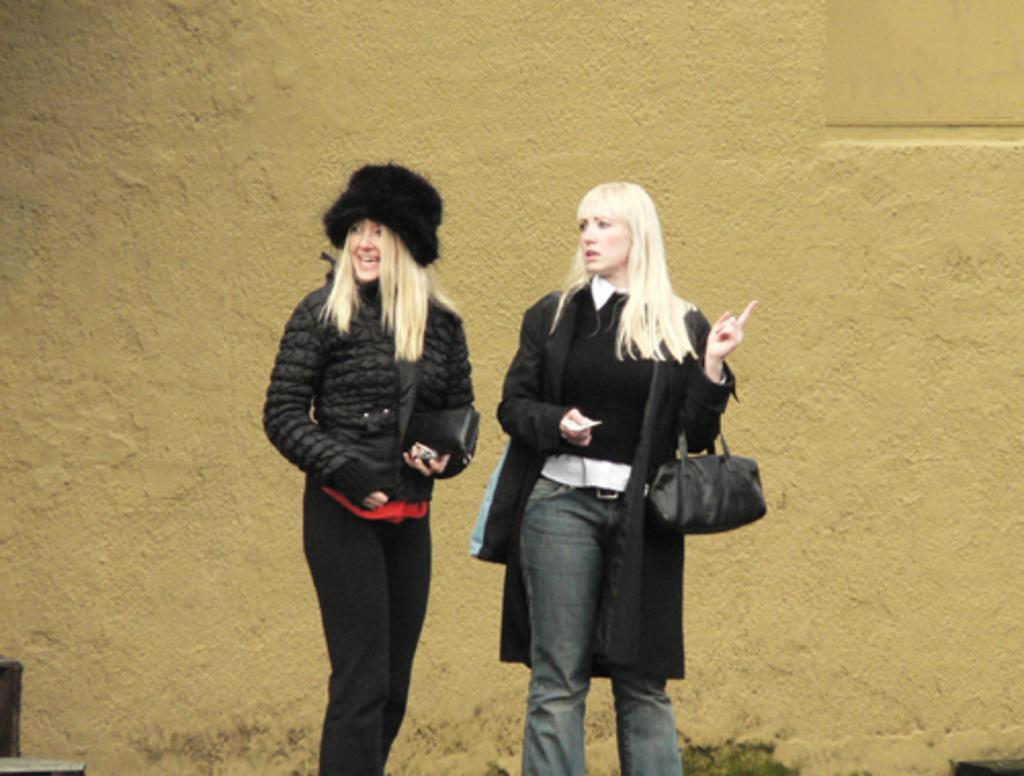How many people are in the image? There are two women in the image. What are the women doing in the image? The women are standing and smiling. What can be seen in the background of the image? There is a wall in the background of the image. What type of attraction can be seen in the image? There is no attraction present in the image; it features two women standing and smiling. What is the occasion for the women's smiles in the image? The image does not specify the occasion for the women's smiles, so we cannot determine if it is a birthday or any other event. 